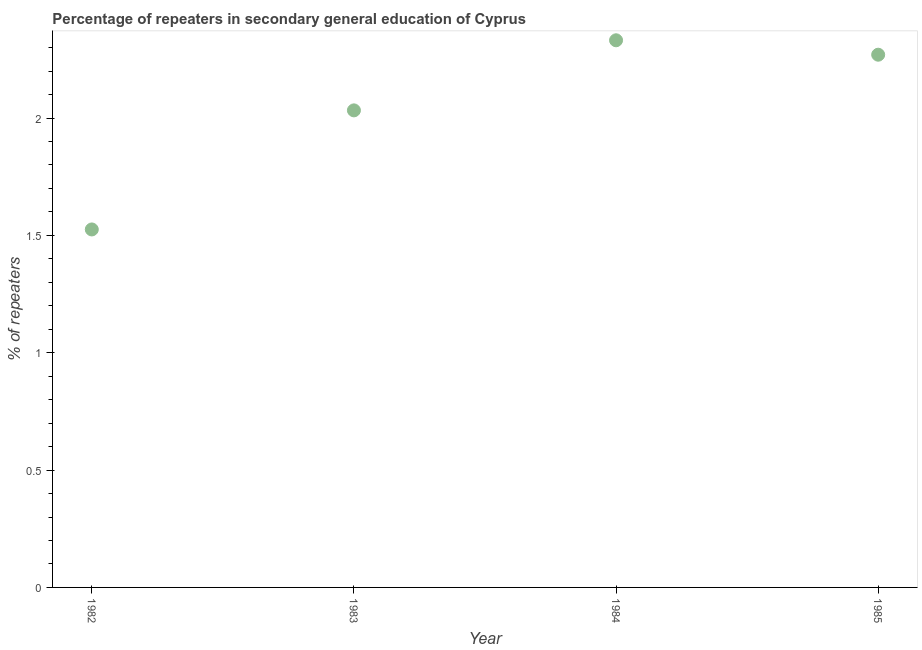What is the percentage of repeaters in 1984?
Your answer should be compact. 2.33. Across all years, what is the maximum percentage of repeaters?
Provide a succinct answer. 2.33. Across all years, what is the minimum percentage of repeaters?
Offer a terse response. 1.53. What is the sum of the percentage of repeaters?
Your answer should be very brief. 8.16. What is the difference between the percentage of repeaters in 1984 and 1985?
Give a very brief answer. 0.06. What is the average percentage of repeaters per year?
Provide a succinct answer. 2.04. What is the median percentage of repeaters?
Your answer should be compact. 2.15. What is the ratio of the percentage of repeaters in 1982 to that in 1983?
Offer a very short reply. 0.75. Is the percentage of repeaters in 1982 less than that in 1984?
Ensure brevity in your answer.  Yes. Is the difference between the percentage of repeaters in 1984 and 1985 greater than the difference between any two years?
Offer a terse response. No. What is the difference between the highest and the second highest percentage of repeaters?
Your answer should be very brief. 0.06. What is the difference between the highest and the lowest percentage of repeaters?
Provide a succinct answer. 0.81. In how many years, is the percentage of repeaters greater than the average percentage of repeaters taken over all years?
Your response must be concise. 2. Does the graph contain grids?
Provide a short and direct response. No. What is the title of the graph?
Offer a terse response. Percentage of repeaters in secondary general education of Cyprus. What is the label or title of the Y-axis?
Keep it short and to the point. % of repeaters. What is the % of repeaters in 1982?
Provide a short and direct response. 1.53. What is the % of repeaters in 1983?
Make the answer very short. 2.03. What is the % of repeaters in 1984?
Your answer should be compact. 2.33. What is the % of repeaters in 1985?
Ensure brevity in your answer.  2.27. What is the difference between the % of repeaters in 1982 and 1983?
Give a very brief answer. -0.51. What is the difference between the % of repeaters in 1982 and 1984?
Keep it short and to the point. -0.81. What is the difference between the % of repeaters in 1982 and 1985?
Make the answer very short. -0.74. What is the difference between the % of repeaters in 1983 and 1984?
Provide a succinct answer. -0.3. What is the difference between the % of repeaters in 1983 and 1985?
Your response must be concise. -0.24. What is the difference between the % of repeaters in 1984 and 1985?
Provide a succinct answer. 0.06. What is the ratio of the % of repeaters in 1982 to that in 1984?
Your response must be concise. 0.65. What is the ratio of the % of repeaters in 1982 to that in 1985?
Provide a succinct answer. 0.67. What is the ratio of the % of repeaters in 1983 to that in 1984?
Offer a terse response. 0.87. What is the ratio of the % of repeaters in 1983 to that in 1985?
Ensure brevity in your answer.  0.9. 